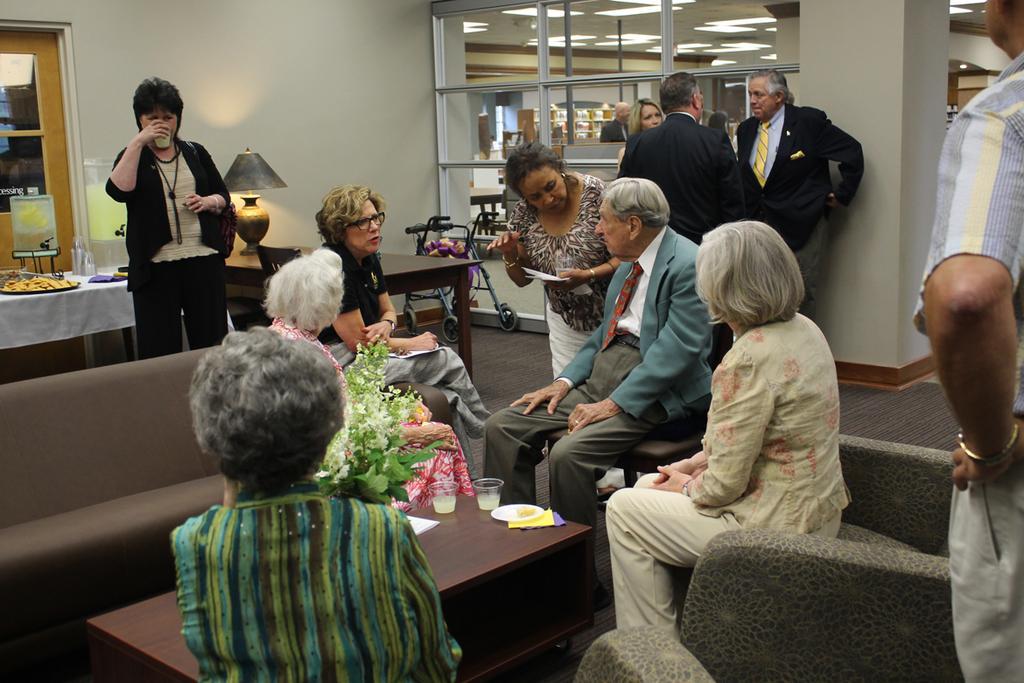Describe this image in one or two sentences. There are few people here sitting and in the background few are standing in this room. We can also see sofas,table and a stroller,lamp and a door. 